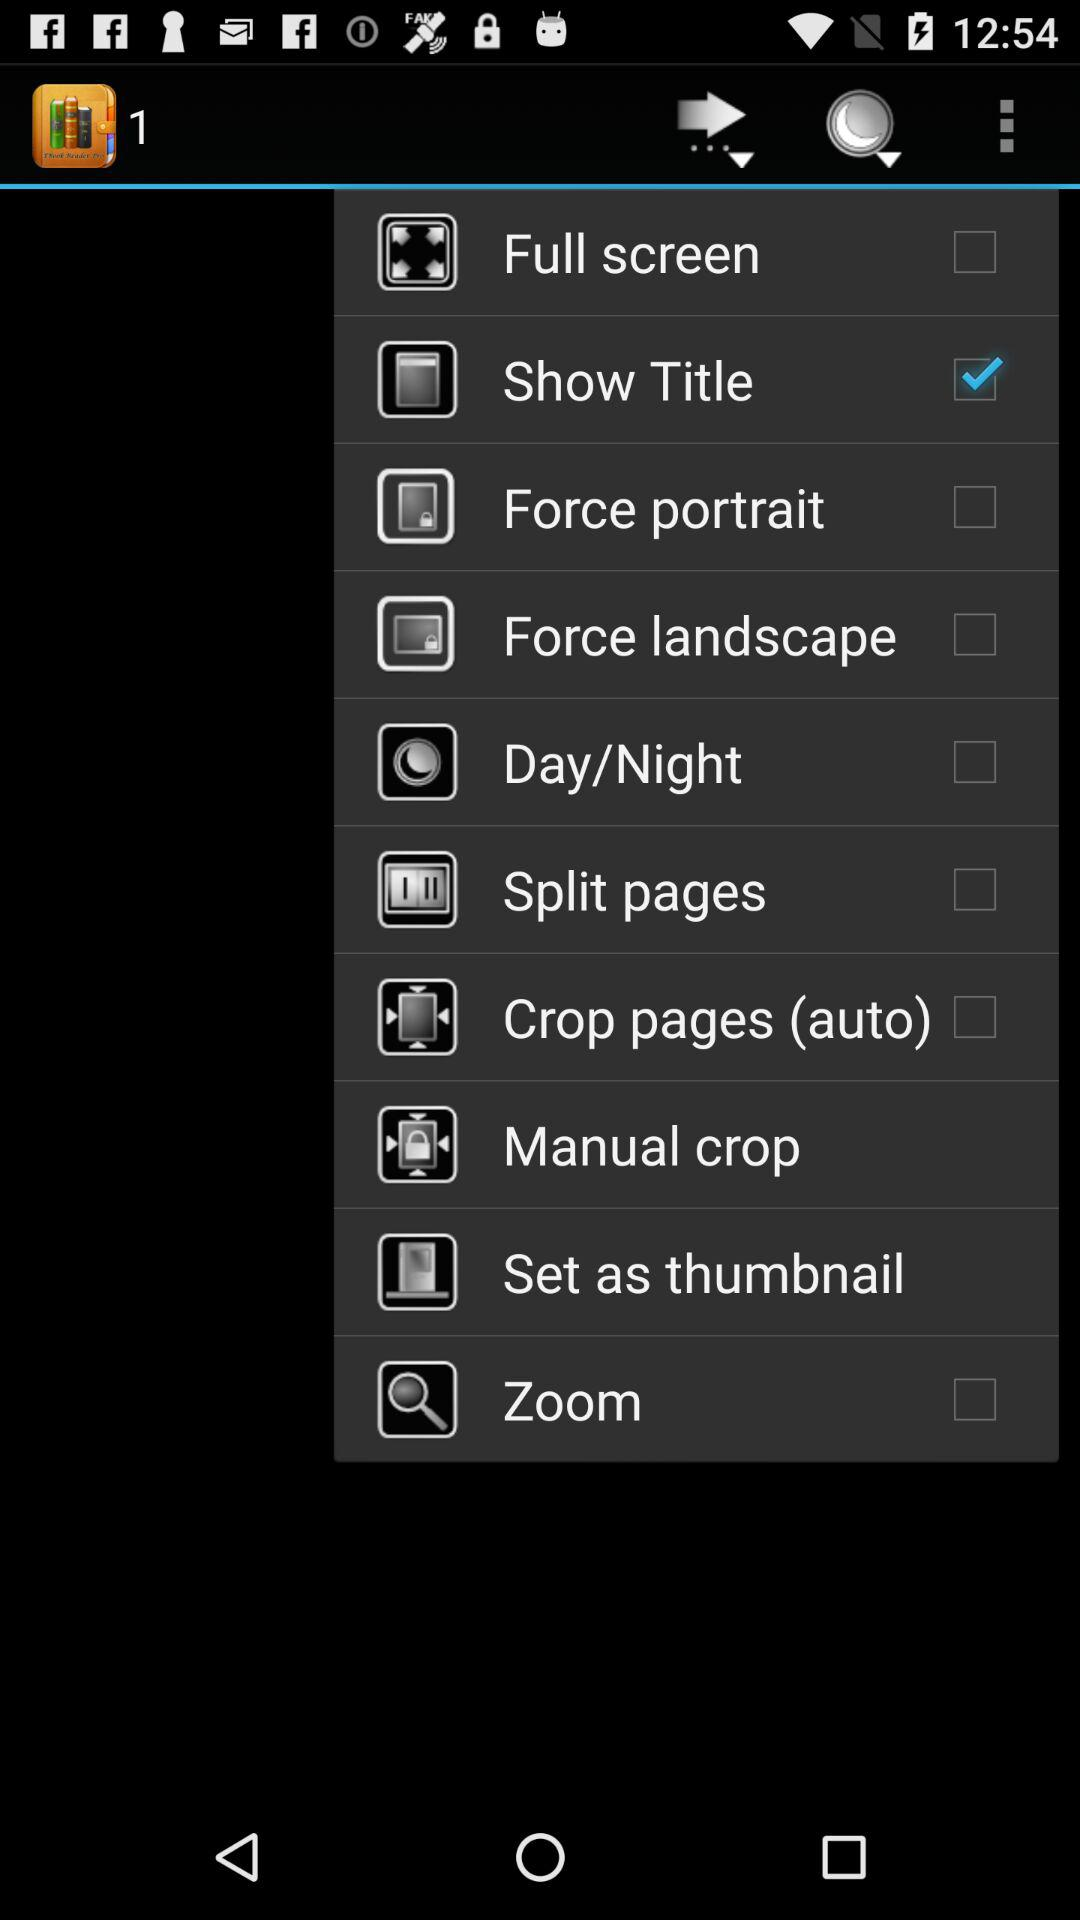What is the selected option? The selected option is "Show Title". 